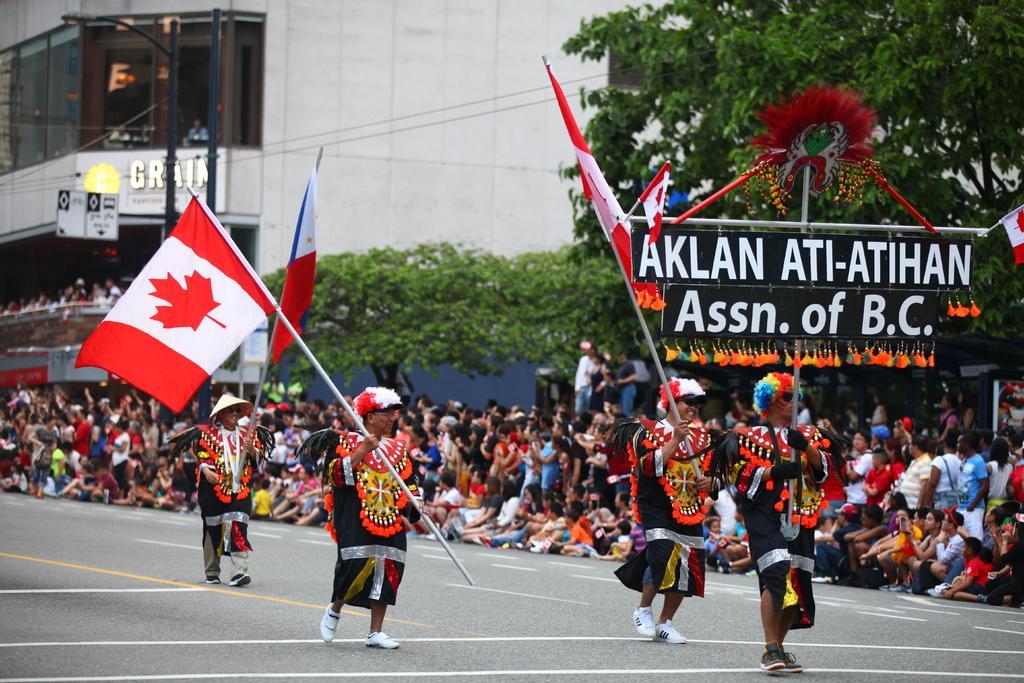Please provide a concise description of this image. In this picture this people are celebrating some festival. Over here this people are holding Canada flag and background all this people are enjoying. 